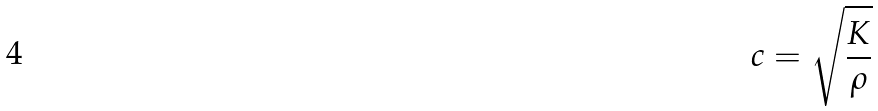<formula> <loc_0><loc_0><loc_500><loc_500>c = \sqrt { \frac { K } { \rho } }</formula> 